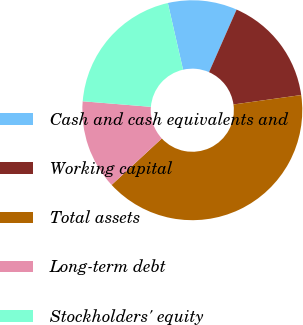Convert chart to OTSL. <chart><loc_0><loc_0><loc_500><loc_500><pie_chart><fcel>Cash and cash equivalents and<fcel>Working capital<fcel>Total assets<fcel>Long-term debt<fcel>Stockholders' equity<nl><fcel>10.17%<fcel>16.2%<fcel>40.32%<fcel>13.18%<fcel>20.13%<nl></chart> 